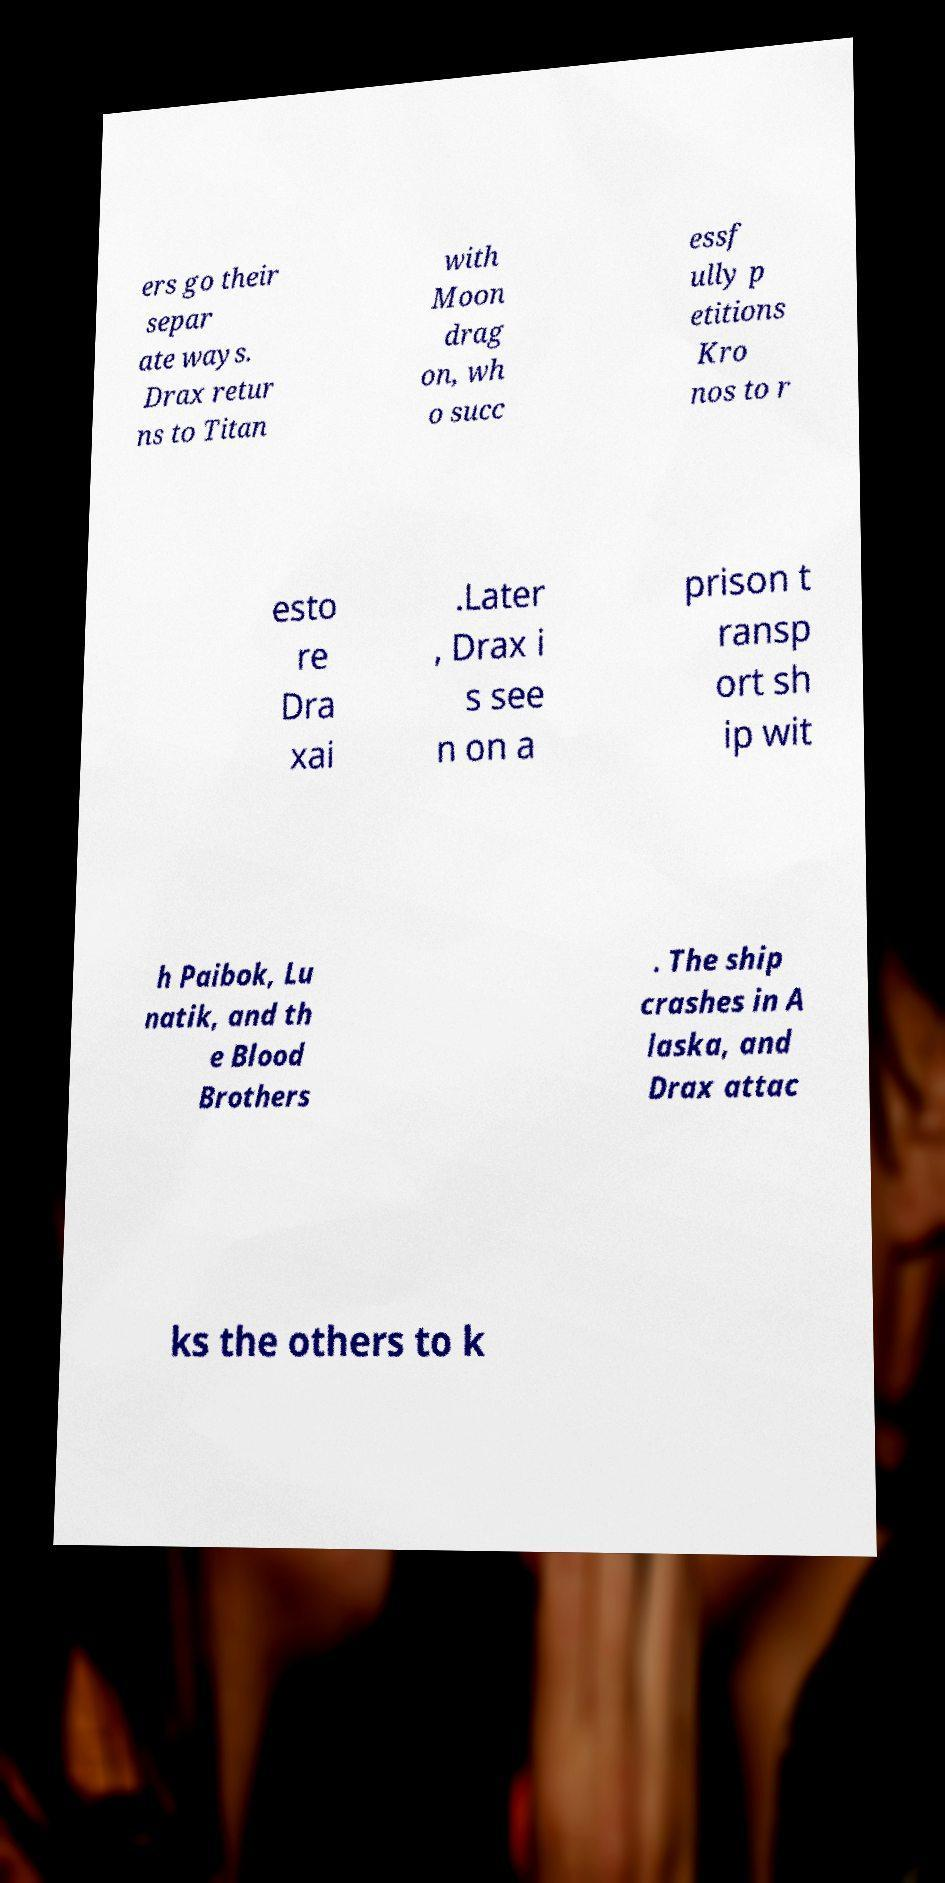Please identify and transcribe the text found in this image. ers go their separ ate ways. Drax retur ns to Titan with Moon drag on, wh o succ essf ully p etitions Kro nos to r esto re Dra xai .Later , Drax i s see n on a prison t ransp ort sh ip wit h Paibok, Lu natik, and th e Blood Brothers . The ship crashes in A laska, and Drax attac ks the others to k 